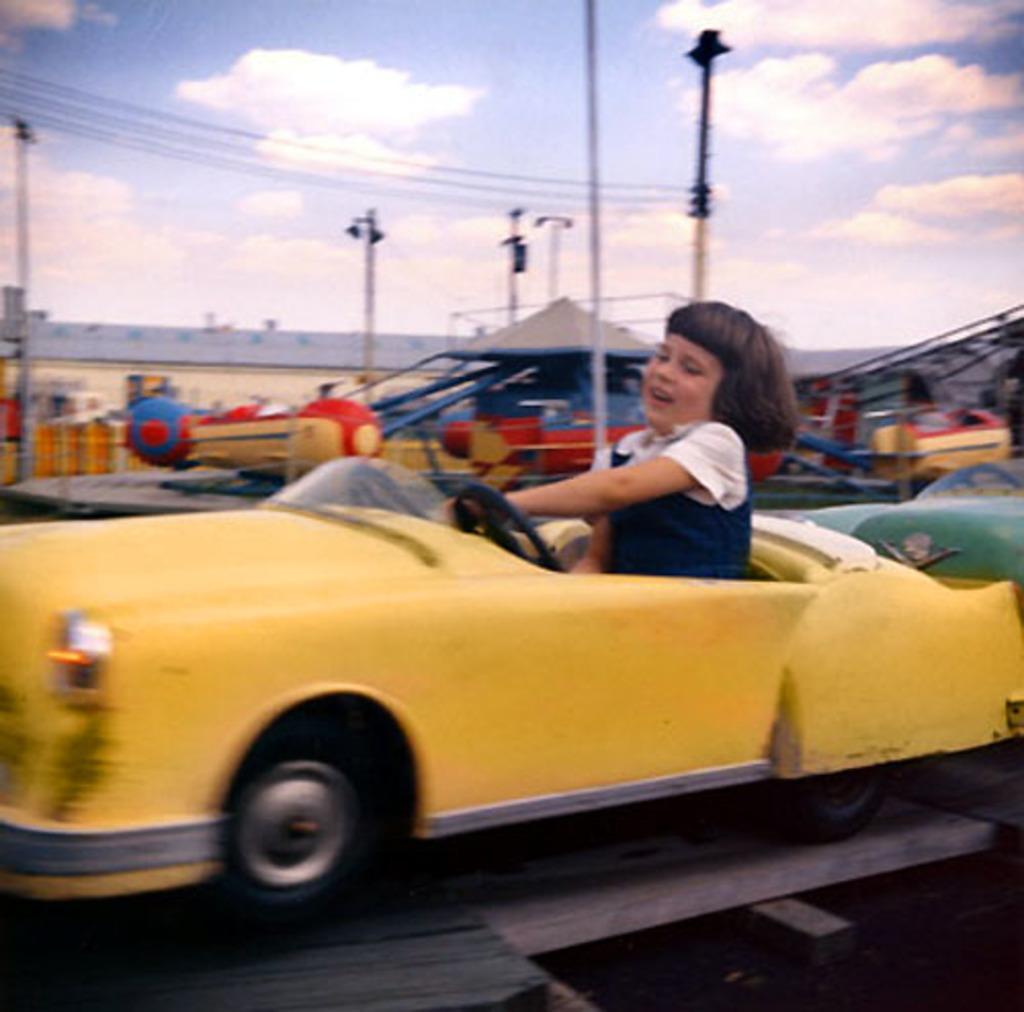In one or two sentences, can you explain what this image depicts? In this picture a girl seated in the toy car and it looks like a fun zone and I can see a building and few poles and a blue cloudy sky. 